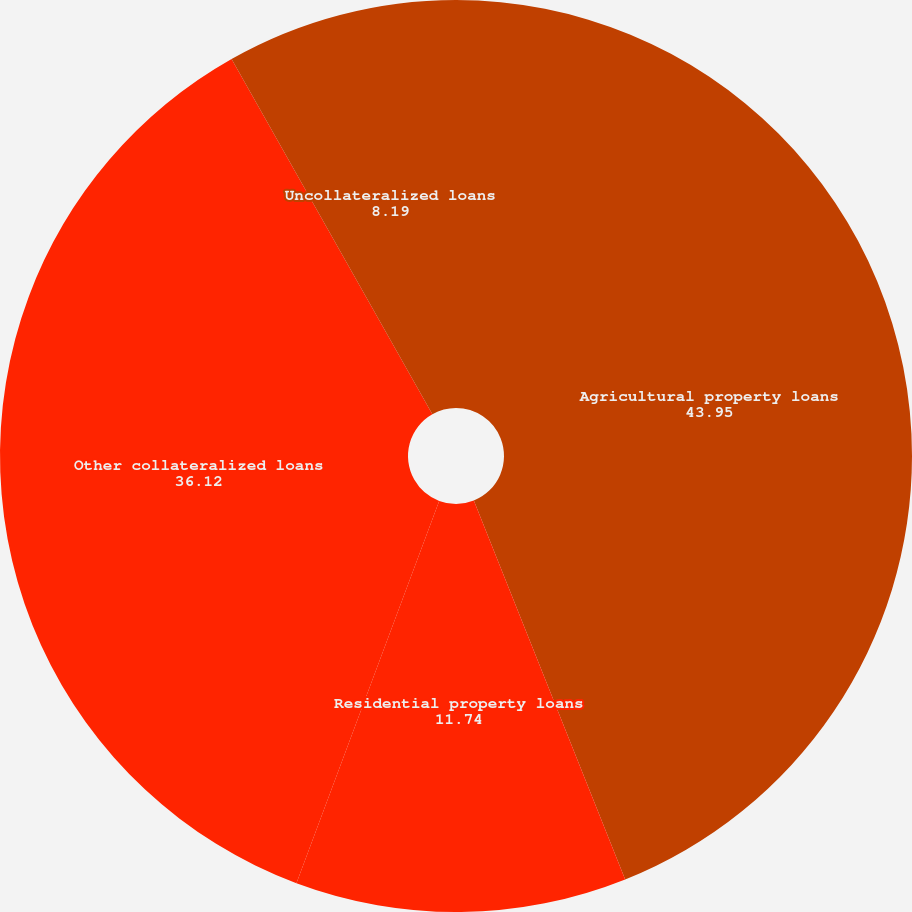Convert chart to OTSL. <chart><loc_0><loc_0><loc_500><loc_500><pie_chart><fcel>Agricultural property loans<fcel>Residential property loans<fcel>Other collateralized loans<fcel>Uncollateralized loans<nl><fcel>43.95%<fcel>11.74%<fcel>36.12%<fcel>8.19%<nl></chart> 